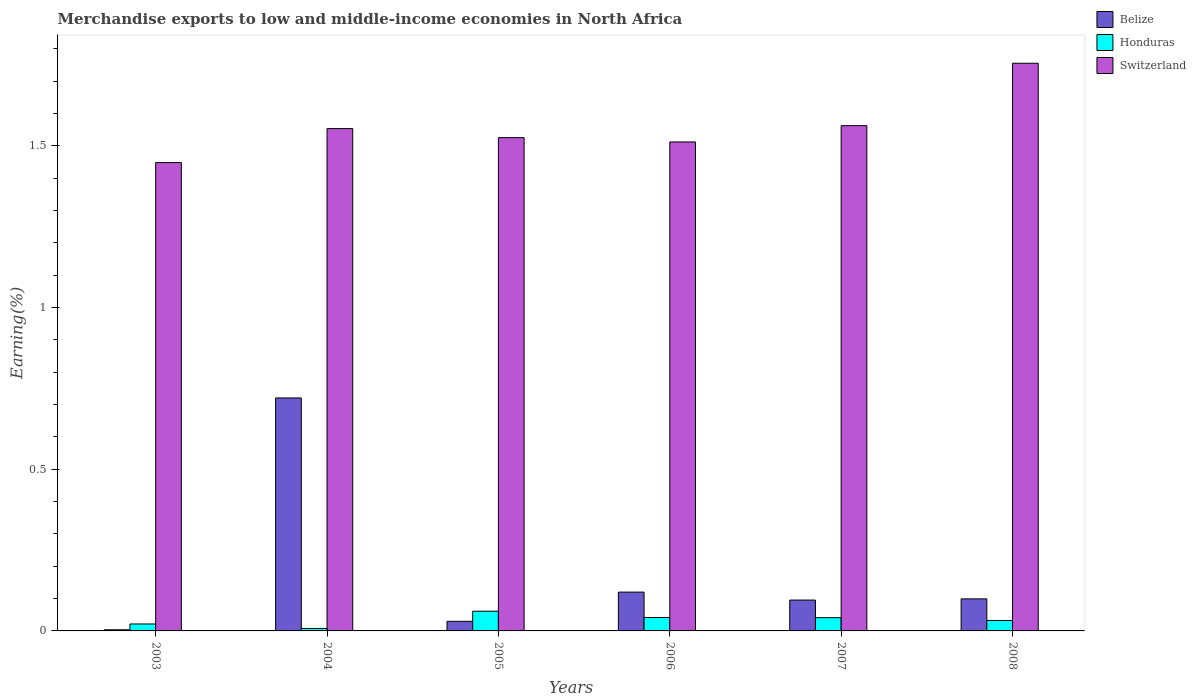How many different coloured bars are there?
Your response must be concise. 3. How many groups of bars are there?
Ensure brevity in your answer.  6. Are the number of bars per tick equal to the number of legend labels?
Keep it short and to the point. Yes. Are the number of bars on each tick of the X-axis equal?
Keep it short and to the point. Yes. How many bars are there on the 1st tick from the right?
Make the answer very short. 3. What is the label of the 4th group of bars from the left?
Ensure brevity in your answer.  2006. In how many cases, is the number of bars for a given year not equal to the number of legend labels?
Your response must be concise. 0. What is the percentage of amount earned from merchandise exports in Belize in 2006?
Your answer should be compact. 0.12. Across all years, what is the maximum percentage of amount earned from merchandise exports in Switzerland?
Provide a succinct answer. 1.76. Across all years, what is the minimum percentage of amount earned from merchandise exports in Belize?
Provide a short and direct response. 0. What is the total percentage of amount earned from merchandise exports in Belize in the graph?
Keep it short and to the point. 1.07. What is the difference between the percentage of amount earned from merchandise exports in Belize in 2005 and that in 2006?
Make the answer very short. -0.09. What is the difference between the percentage of amount earned from merchandise exports in Honduras in 2003 and the percentage of amount earned from merchandise exports in Switzerland in 2006?
Give a very brief answer. -1.49. What is the average percentage of amount earned from merchandise exports in Switzerland per year?
Offer a very short reply. 1.56. In the year 2007, what is the difference between the percentage of amount earned from merchandise exports in Switzerland and percentage of amount earned from merchandise exports in Belize?
Give a very brief answer. 1.47. What is the ratio of the percentage of amount earned from merchandise exports in Honduras in 2003 to that in 2006?
Your answer should be very brief. 0.52. Is the difference between the percentage of amount earned from merchandise exports in Switzerland in 2004 and 2005 greater than the difference between the percentage of amount earned from merchandise exports in Belize in 2004 and 2005?
Offer a very short reply. No. What is the difference between the highest and the second highest percentage of amount earned from merchandise exports in Belize?
Give a very brief answer. 0.6. What is the difference between the highest and the lowest percentage of amount earned from merchandise exports in Switzerland?
Your response must be concise. 0.31. Is the sum of the percentage of amount earned from merchandise exports in Switzerland in 2005 and 2008 greater than the maximum percentage of amount earned from merchandise exports in Belize across all years?
Your answer should be compact. Yes. What does the 3rd bar from the left in 2006 represents?
Offer a very short reply. Switzerland. What does the 1st bar from the right in 2008 represents?
Provide a short and direct response. Switzerland. How many bars are there?
Your response must be concise. 18. How many years are there in the graph?
Offer a very short reply. 6. Where does the legend appear in the graph?
Offer a terse response. Top right. How many legend labels are there?
Your answer should be very brief. 3. How are the legend labels stacked?
Provide a succinct answer. Vertical. What is the title of the graph?
Provide a succinct answer. Merchandise exports to low and middle-income economies in North Africa. What is the label or title of the Y-axis?
Provide a succinct answer. Earning(%). What is the Earning(%) in Belize in 2003?
Give a very brief answer. 0. What is the Earning(%) of Honduras in 2003?
Keep it short and to the point. 0.02. What is the Earning(%) in Switzerland in 2003?
Keep it short and to the point. 1.45. What is the Earning(%) of Belize in 2004?
Provide a succinct answer. 0.72. What is the Earning(%) of Honduras in 2004?
Ensure brevity in your answer.  0.01. What is the Earning(%) in Switzerland in 2004?
Make the answer very short. 1.55. What is the Earning(%) in Belize in 2005?
Offer a very short reply. 0.03. What is the Earning(%) in Honduras in 2005?
Your answer should be very brief. 0.06. What is the Earning(%) in Switzerland in 2005?
Your response must be concise. 1.53. What is the Earning(%) in Belize in 2006?
Your response must be concise. 0.12. What is the Earning(%) of Honduras in 2006?
Offer a terse response. 0.04. What is the Earning(%) of Switzerland in 2006?
Your answer should be compact. 1.51. What is the Earning(%) in Belize in 2007?
Keep it short and to the point. 0.1. What is the Earning(%) in Honduras in 2007?
Your response must be concise. 0.04. What is the Earning(%) of Switzerland in 2007?
Your answer should be very brief. 1.56. What is the Earning(%) of Belize in 2008?
Keep it short and to the point. 0.1. What is the Earning(%) of Honduras in 2008?
Your answer should be very brief. 0.03. What is the Earning(%) in Switzerland in 2008?
Provide a short and direct response. 1.76. Across all years, what is the maximum Earning(%) in Belize?
Your answer should be very brief. 0.72. Across all years, what is the maximum Earning(%) of Honduras?
Ensure brevity in your answer.  0.06. Across all years, what is the maximum Earning(%) in Switzerland?
Give a very brief answer. 1.76. Across all years, what is the minimum Earning(%) of Belize?
Make the answer very short. 0. Across all years, what is the minimum Earning(%) in Honduras?
Your answer should be compact. 0.01. Across all years, what is the minimum Earning(%) of Switzerland?
Your answer should be compact. 1.45. What is the total Earning(%) of Belize in the graph?
Give a very brief answer. 1.07. What is the total Earning(%) in Honduras in the graph?
Give a very brief answer. 0.2. What is the total Earning(%) in Switzerland in the graph?
Provide a short and direct response. 9.36. What is the difference between the Earning(%) in Belize in 2003 and that in 2004?
Keep it short and to the point. -0.72. What is the difference between the Earning(%) in Honduras in 2003 and that in 2004?
Make the answer very short. 0.01. What is the difference between the Earning(%) of Switzerland in 2003 and that in 2004?
Provide a short and direct response. -0.11. What is the difference between the Earning(%) in Belize in 2003 and that in 2005?
Offer a very short reply. -0.03. What is the difference between the Earning(%) in Honduras in 2003 and that in 2005?
Provide a succinct answer. -0.04. What is the difference between the Earning(%) of Switzerland in 2003 and that in 2005?
Your answer should be compact. -0.08. What is the difference between the Earning(%) in Belize in 2003 and that in 2006?
Ensure brevity in your answer.  -0.12. What is the difference between the Earning(%) in Honduras in 2003 and that in 2006?
Make the answer very short. -0.02. What is the difference between the Earning(%) in Switzerland in 2003 and that in 2006?
Offer a terse response. -0.06. What is the difference between the Earning(%) in Belize in 2003 and that in 2007?
Your answer should be compact. -0.09. What is the difference between the Earning(%) of Honduras in 2003 and that in 2007?
Ensure brevity in your answer.  -0.02. What is the difference between the Earning(%) of Switzerland in 2003 and that in 2007?
Keep it short and to the point. -0.11. What is the difference between the Earning(%) in Belize in 2003 and that in 2008?
Make the answer very short. -0.1. What is the difference between the Earning(%) in Honduras in 2003 and that in 2008?
Provide a succinct answer. -0.01. What is the difference between the Earning(%) of Switzerland in 2003 and that in 2008?
Keep it short and to the point. -0.31. What is the difference between the Earning(%) in Belize in 2004 and that in 2005?
Ensure brevity in your answer.  0.69. What is the difference between the Earning(%) in Honduras in 2004 and that in 2005?
Ensure brevity in your answer.  -0.05. What is the difference between the Earning(%) in Switzerland in 2004 and that in 2005?
Ensure brevity in your answer.  0.03. What is the difference between the Earning(%) of Belize in 2004 and that in 2006?
Your response must be concise. 0.6. What is the difference between the Earning(%) in Honduras in 2004 and that in 2006?
Ensure brevity in your answer.  -0.03. What is the difference between the Earning(%) of Switzerland in 2004 and that in 2006?
Your response must be concise. 0.04. What is the difference between the Earning(%) of Belize in 2004 and that in 2007?
Your answer should be compact. 0.63. What is the difference between the Earning(%) of Honduras in 2004 and that in 2007?
Make the answer very short. -0.03. What is the difference between the Earning(%) of Switzerland in 2004 and that in 2007?
Your response must be concise. -0.01. What is the difference between the Earning(%) of Belize in 2004 and that in 2008?
Provide a short and direct response. 0.62. What is the difference between the Earning(%) of Honduras in 2004 and that in 2008?
Keep it short and to the point. -0.02. What is the difference between the Earning(%) of Switzerland in 2004 and that in 2008?
Your response must be concise. -0.2. What is the difference between the Earning(%) in Belize in 2005 and that in 2006?
Your answer should be compact. -0.09. What is the difference between the Earning(%) in Honduras in 2005 and that in 2006?
Your answer should be very brief. 0.02. What is the difference between the Earning(%) of Switzerland in 2005 and that in 2006?
Provide a short and direct response. 0.01. What is the difference between the Earning(%) in Belize in 2005 and that in 2007?
Give a very brief answer. -0.07. What is the difference between the Earning(%) of Honduras in 2005 and that in 2007?
Provide a short and direct response. 0.02. What is the difference between the Earning(%) of Switzerland in 2005 and that in 2007?
Make the answer very short. -0.04. What is the difference between the Earning(%) of Belize in 2005 and that in 2008?
Offer a very short reply. -0.07. What is the difference between the Earning(%) in Honduras in 2005 and that in 2008?
Offer a terse response. 0.03. What is the difference between the Earning(%) of Switzerland in 2005 and that in 2008?
Your answer should be compact. -0.23. What is the difference between the Earning(%) of Belize in 2006 and that in 2007?
Your response must be concise. 0.02. What is the difference between the Earning(%) in Honduras in 2006 and that in 2007?
Your answer should be very brief. 0. What is the difference between the Earning(%) of Switzerland in 2006 and that in 2007?
Make the answer very short. -0.05. What is the difference between the Earning(%) of Belize in 2006 and that in 2008?
Your answer should be very brief. 0.02. What is the difference between the Earning(%) in Honduras in 2006 and that in 2008?
Keep it short and to the point. 0.01. What is the difference between the Earning(%) of Switzerland in 2006 and that in 2008?
Your answer should be very brief. -0.24. What is the difference between the Earning(%) of Belize in 2007 and that in 2008?
Your answer should be compact. -0. What is the difference between the Earning(%) in Honduras in 2007 and that in 2008?
Ensure brevity in your answer.  0.01. What is the difference between the Earning(%) of Switzerland in 2007 and that in 2008?
Provide a short and direct response. -0.19. What is the difference between the Earning(%) of Belize in 2003 and the Earning(%) of Honduras in 2004?
Offer a very short reply. -0. What is the difference between the Earning(%) in Belize in 2003 and the Earning(%) in Switzerland in 2004?
Give a very brief answer. -1.55. What is the difference between the Earning(%) in Honduras in 2003 and the Earning(%) in Switzerland in 2004?
Your answer should be compact. -1.53. What is the difference between the Earning(%) in Belize in 2003 and the Earning(%) in Honduras in 2005?
Give a very brief answer. -0.06. What is the difference between the Earning(%) of Belize in 2003 and the Earning(%) of Switzerland in 2005?
Your answer should be very brief. -1.52. What is the difference between the Earning(%) in Honduras in 2003 and the Earning(%) in Switzerland in 2005?
Give a very brief answer. -1.5. What is the difference between the Earning(%) of Belize in 2003 and the Earning(%) of Honduras in 2006?
Your response must be concise. -0.04. What is the difference between the Earning(%) of Belize in 2003 and the Earning(%) of Switzerland in 2006?
Keep it short and to the point. -1.51. What is the difference between the Earning(%) in Honduras in 2003 and the Earning(%) in Switzerland in 2006?
Offer a terse response. -1.49. What is the difference between the Earning(%) in Belize in 2003 and the Earning(%) in Honduras in 2007?
Give a very brief answer. -0.04. What is the difference between the Earning(%) in Belize in 2003 and the Earning(%) in Switzerland in 2007?
Keep it short and to the point. -1.56. What is the difference between the Earning(%) in Honduras in 2003 and the Earning(%) in Switzerland in 2007?
Make the answer very short. -1.54. What is the difference between the Earning(%) in Belize in 2003 and the Earning(%) in Honduras in 2008?
Ensure brevity in your answer.  -0.03. What is the difference between the Earning(%) of Belize in 2003 and the Earning(%) of Switzerland in 2008?
Ensure brevity in your answer.  -1.75. What is the difference between the Earning(%) of Honduras in 2003 and the Earning(%) of Switzerland in 2008?
Offer a terse response. -1.73. What is the difference between the Earning(%) of Belize in 2004 and the Earning(%) of Honduras in 2005?
Offer a very short reply. 0.66. What is the difference between the Earning(%) of Belize in 2004 and the Earning(%) of Switzerland in 2005?
Provide a succinct answer. -0.81. What is the difference between the Earning(%) in Honduras in 2004 and the Earning(%) in Switzerland in 2005?
Your answer should be compact. -1.52. What is the difference between the Earning(%) in Belize in 2004 and the Earning(%) in Honduras in 2006?
Your answer should be very brief. 0.68. What is the difference between the Earning(%) of Belize in 2004 and the Earning(%) of Switzerland in 2006?
Provide a succinct answer. -0.79. What is the difference between the Earning(%) in Honduras in 2004 and the Earning(%) in Switzerland in 2006?
Offer a terse response. -1.5. What is the difference between the Earning(%) of Belize in 2004 and the Earning(%) of Honduras in 2007?
Your answer should be compact. 0.68. What is the difference between the Earning(%) in Belize in 2004 and the Earning(%) in Switzerland in 2007?
Your answer should be very brief. -0.84. What is the difference between the Earning(%) in Honduras in 2004 and the Earning(%) in Switzerland in 2007?
Provide a succinct answer. -1.55. What is the difference between the Earning(%) of Belize in 2004 and the Earning(%) of Honduras in 2008?
Provide a short and direct response. 0.69. What is the difference between the Earning(%) of Belize in 2004 and the Earning(%) of Switzerland in 2008?
Offer a terse response. -1.03. What is the difference between the Earning(%) in Honduras in 2004 and the Earning(%) in Switzerland in 2008?
Ensure brevity in your answer.  -1.75. What is the difference between the Earning(%) of Belize in 2005 and the Earning(%) of Honduras in 2006?
Provide a succinct answer. -0.01. What is the difference between the Earning(%) of Belize in 2005 and the Earning(%) of Switzerland in 2006?
Offer a terse response. -1.48. What is the difference between the Earning(%) in Honduras in 2005 and the Earning(%) in Switzerland in 2006?
Your answer should be very brief. -1.45. What is the difference between the Earning(%) in Belize in 2005 and the Earning(%) in Honduras in 2007?
Provide a short and direct response. -0.01. What is the difference between the Earning(%) in Belize in 2005 and the Earning(%) in Switzerland in 2007?
Your answer should be compact. -1.53. What is the difference between the Earning(%) in Honduras in 2005 and the Earning(%) in Switzerland in 2007?
Give a very brief answer. -1.5. What is the difference between the Earning(%) in Belize in 2005 and the Earning(%) in Honduras in 2008?
Make the answer very short. -0. What is the difference between the Earning(%) in Belize in 2005 and the Earning(%) in Switzerland in 2008?
Your answer should be compact. -1.73. What is the difference between the Earning(%) in Honduras in 2005 and the Earning(%) in Switzerland in 2008?
Offer a very short reply. -1.69. What is the difference between the Earning(%) in Belize in 2006 and the Earning(%) in Honduras in 2007?
Your answer should be compact. 0.08. What is the difference between the Earning(%) in Belize in 2006 and the Earning(%) in Switzerland in 2007?
Your answer should be compact. -1.44. What is the difference between the Earning(%) in Honduras in 2006 and the Earning(%) in Switzerland in 2007?
Your answer should be compact. -1.52. What is the difference between the Earning(%) in Belize in 2006 and the Earning(%) in Honduras in 2008?
Make the answer very short. 0.09. What is the difference between the Earning(%) of Belize in 2006 and the Earning(%) of Switzerland in 2008?
Your answer should be very brief. -1.64. What is the difference between the Earning(%) in Honduras in 2006 and the Earning(%) in Switzerland in 2008?
Your response must be concise. -1.71. What is the difference between the Earning(%) in Belize in 2007 and the Earning(%) in Honduras in 2008?
Keep it short and to the point. 0.06. What is the difference between the Earning(%) of Belize in 2007 and the Earning(%) of Switzerland in 2008?
Offer a terse response. -1.66. What is the difference between the Earning(%) of Honduras in 2007 and the Earning(%) of Switzerland in 2008?
Ensure brevity in your answer.  -1.71. What is the average Earning(%) in Belize per year?
Keep it short and to the point. 0.18. What is the average Earning(%) in Honduras per year?
Offer a terse response. 0.03. What is the average Earning(%) of Switzerland per year?
Provide a short and direct response. 1.56. In the year 2003, what is the difference between the Earning(%) in Belize and Earning(%) in Honduras?
Your response must be concise. -0.02. In the year 2003, what is the difference between the Earning(%) of Belize and Earning(%) of Switzerland?
Provide a succinct answer. -1.44. In the year 2003, what is the difference between the Earning(%) of Honduras and Earning(%) of Switzerland?
Provide a short and direct response. -1.43. In the year 2004, what is the difference between the Earning(%) in Belize and Earning(%) in Honduras?
Your response must be concise. 0.71. In the year 2004, what is the difference between the Earning(%) of Belize and Earning(%) of Switzerland?
Offer a very short reply. -0.83. In the year 2004, what is the difference between the Earning(%) in Honduras and Earning(%) in Switzerland?
Ensure brevity in your answer.  -1.55. In the year 2005, what is the difference between the Earning(%) of Belize and Earning(%) of Honduras?
Your response must be concise. -0.03. In the year 2005, what is the difference between the Earning(%) in Belize and Earning(%) in Switzerland?
Offer a very short reply. -1.5. In the year 2005, what is the difference between the Earning(%) of Honduras and Earning(%) of Switzerland?
Offer a very short reply. -1.46. In the year 2006, what is the difference between the Earning(%) in Belize and Earning(%) in Honduras?
Keep it short and to the point. 0.08. In the year 2006, what is the difference between the Earning(%) of Belize and Earning(%) of Switzerland?
Provide a succinct answer. -1.39. In the year 2006, what is the difference between the Earning(%) of Honduras and Earning(%) of Switzerland?
Offer a terse response. -1.47. In the year 2007, what is the difference between the Earning(%) of Belize and Earning(%) of Honduras?
Keep it short and to the point. 0.05. In the year 2007, what is the difference between the Earning(%) in Belize and Earning(%) in Switzerland?
Provide a succinct answer. -1.47. In the year 2007, what is the difference between the Earning(%) in Honduras and Earning(%) in Switzerland?
Your response must be concise. -1.52. In the year 2008, what is the difference between the Earning(%) in Belize and Earning(%) in Honduras?
Give a very brief answer. 0.07. In the year 2008, what is the difference between the Earning(%) in Belize and Earning(%) in Switzerland?
Your response must be concise. -1.66. In the year 2008, what is the difference between the Earning(%) in Honduras and Earning(%) in Switzerland?
Make the answer very short. -1.72. What is the ratio of the Earning(%) in Belize in 2003 to that in 2004?
Keep it short and to the point. 0. What is the ratio of the Earning(%) of Honduras in 2003 to that in 2004?
Provide a short and direct response. 2.83. What is the ratio of the Earning(%) of Switzerland in 2003 to that in 2004?
Provide a short and direct response. 0.93. What is the ratio of the Earning(%) in Belize in 2003 to that in 2005?
Your answer should be compact. 0.12. What is the ratio of the Earning(%) of Honduras in 2003 to that in 2005?
Your answer should be very brief. 0.35. What is the ratio of the Earning(%) of Switzerland in 2003 to that in 2005?
Your response must be concise. 0.95. What is the ratio of the Earning(%) in Belize in 2003 to that in 2006?
Your answer should be very brief. 0.03. What is the ratio of the Earning(%) of Honduras in 2003 to that in 2006?
Give a very brief answer. 0.52. What is the ratio of the Earning(%) of Switzerland in 2003 to that in 2006?
Your answer should be compact. 0.96. What is the ratio of the Earning(%) in Belize in 2003 to that in 2007?
Make the answer very short. 0.04. What is the ratio of the Earning(%) in Honduras in 2003 to that in 2007?
Ensure brevity in your answer.  0.53. What is the ratio of the Earning(%) of Switzerland in 2003 to that in 2007?
Offer a terse response. 0.93. What is the ratio of the Earning(%) in Belize in 2003 to that in 2008?
Your answer should be very brief. 0.04. What is the ratio of the Earning(%) of Honduras in 2003 to that in 2008?
Keep it short and to the point. 0.67. What is the ratio of the Earning(%) of Switzerland in 2003 to that in 2008?
Make the answer very short. 0.83. What is the ratio of the Earning(%) in Belize in 2004 to that in 2005?
Offer a terse response. 24.24. What is the ratio of the Earning(%) in Honduras in 2004 to that in 2005?
Provide a succinct answer. 0.12. What is the ratio of the Earning(%) of Switzerland in 2004 to that in 2005?
Provide a succinct answer. 1.02. What is the ratio of the Earning(%) in Belize in 2004 to that in 2006?
Your answer should be compact. 6. What is the ratio of the Earning(%) in Honduras in 2004 to that in 2006?
Ensure brevity in your answer.  0.18. What is the ratio of the Earning(%) in Switzerland in 2004 to that in 2006?
Offer a terse response. 1.03. What is the ratio of the Earning(%) in Belize in 2004 to that in 2007?
Your answer should be very brief. 7.55. What is the ratio of the Earning(%) in Honduras in 2004 to that in 2007?
Keep it short and to the point. 0.19. What is the ratio of the Earning(%) of Switzerland in 2004 to that in 2007?
Your answer should be compact. 0.99. What is the ratio of the Earning(%) of Belize in 2004 to that in 2008?
Ensure brevity in your answer.  7.27. What is the ratio of the Earning(%) in Honduras in 2004 to that in 2008?
Make the answer very short. 0.24. What is the ratio of the Earning(%) in Switzerland in 2004 to that in 2008?
Your response must be concise. 0.88. What is the ratio of the Earning(%) of Belize in 2005 to that in 2006?
Your answer should be compact. 0.25. What is the ratio of the Earning(%) of Honduras in 2005 to that in 2006?
Give a very brief answer. 1.47. What is the ratio of the Earning(%) in Switzerland in 2005 to that in 2006?
Your response must be concise. 1.01. What is the ratio of the Earning(%) in Belize in 2005 to that in 2007?
Your answer should be compact. 0.31. What is the ratio of the Earning(%) in Honduras in 2005 to that in 2007?
Your answer should be compact. 1.49. What is the ratio of the Earning(%) in Switzerland in 2005 to that in 2007?
Give a very brief answer. 0.98. What is the ratio of the Earning(%) in Belize in 2005 to that in 2008?
Your response must be concise. 0.3. What is the ratio of the Earning(%) in Honduras in 2005 to that in 2008?
Give a very brief answer. 1.89. What is the ratio of the Earning(%) in Switzerland in 2005 to that in 2008?
Make the answer very short. 0.87. What is the ratio of the Earning(%) in Belize in 2006 to that in 2007?
Your answer should be very brief. 1.26. What is the ratio of the Earning(%) of Honduras in 2006 to that in 2007?
Ensure brevity in your answer.  1.01. What is the ratio of the Earning(%) of Switzerland in 2006 to that in 2007?
Your answer should be very brief. 0.97. What is the ratio of the Earning(%) of Belize in 2006 to that in 2008?
Your answer should be compact. 1.21. What is the ratio of the Earning(%) of Honduras in 2006 to that in 2008?
Your answer should be very brief. 1.29. What is the ratio of the Earning(%) in Switzerland in 2006 to that in 2008?
Keep it short and to the point. 0.86. What is the ratio of the Earning(%) in Belize in 2007 to that in 2008?
Ensure brevity in your answer.  0.96. What is the ratio of the Earning(%) in Honduras in 2007 to that in 2008?
Make the answer very short. 1.27. What is the ratio of the Earning(%) in Switzerland in 2007 to that in 2008?
Offer a very short reply. 0.89. What is the difference between the highest and the second highest Earning(%) in Belize?
Make the answer very short. 0.6. What is the difference between the highest and the second highest Earning(%) in Honduras?
Offer a very short reply. 0.02. What is the difference between the highest and the second highest Earning(%) of Switzerland?
Offer a very short reply. 0.19. What is the difference between the highest and the lowest Earning(%) of Belize?
Your response must be concise. 0.72. What is the difference between the highest and the lowest Earning(%) in Honduras?
Make the answer very short. 0.05. What is the difference between the highest and the lowest Earning(%) in Switzerland?
Your response must be concise. 0.31. 